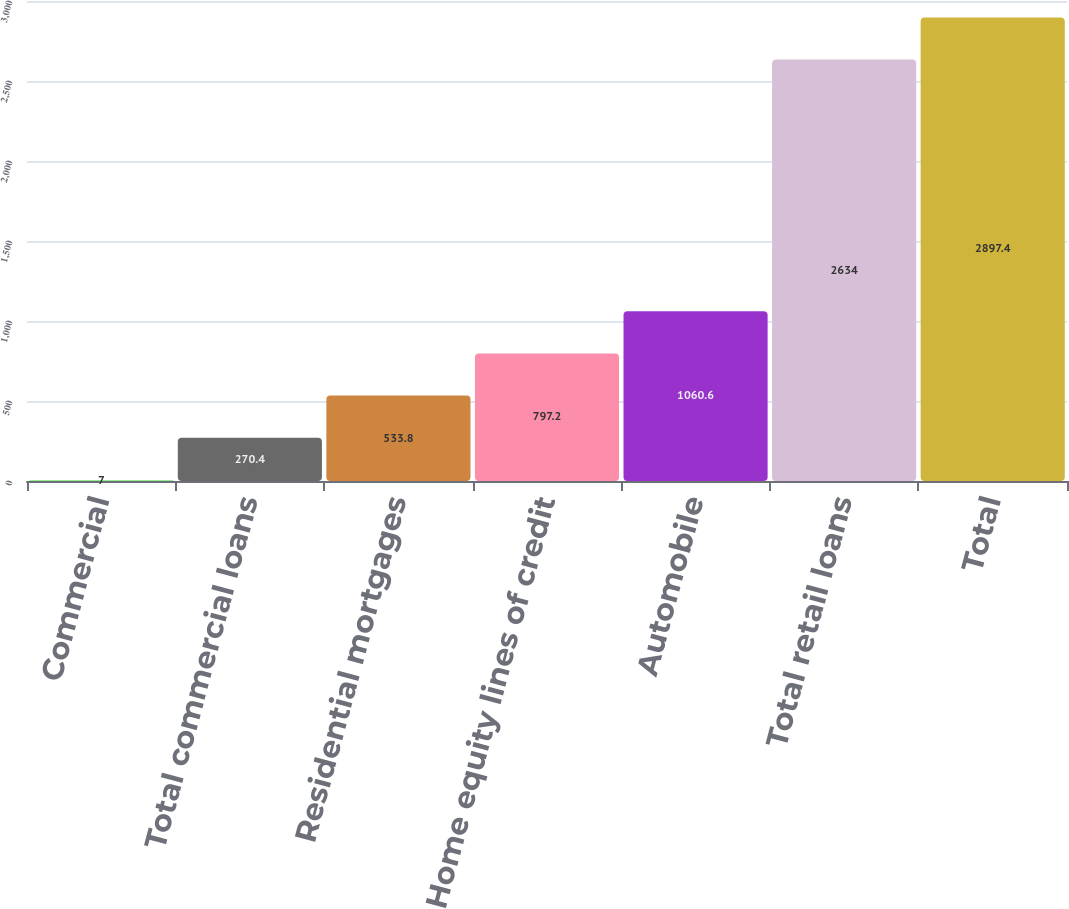Convert chart to OTSL. <chart><loc_0><loc_0><loc_500><loc_500><bar_chart><fcel>Commercial<fcel>Total commercial loans<fcel>Residential mortgages<fcel>Home equity lines of credit<fcel>Automobile<fcel>Total retail loans<fcel>Total<nl><fcel>7<fcel>270.4<fcel>533.8<fcel>797.2<fcel>1060.6<fcel>2634<fcel>2897.4<nl></chart> 